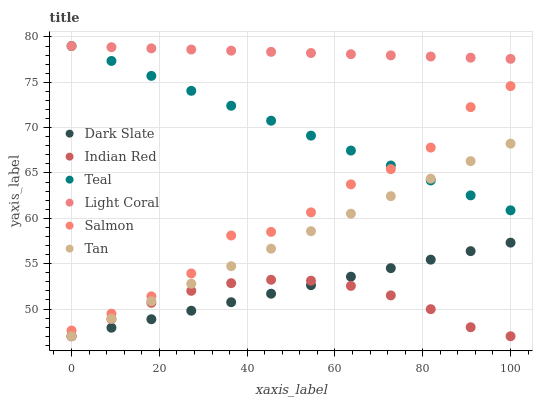Does Indian Red have the minimum area under the curve?
Answer yes or no. Yes. Does Light Coral have the maximum area under the curve?
Answer yes or no. Yes. Does Salmon have the minimum area under the curve?
Answer yes or no. No. Does Salmon have the maximum area under the curve?
Answer yes or no. No. Is Dark Slate the smoothest?
Answer yes or no. Yes. Is Salmon the roughest?
Answer yes or no. Yes. Is Light Coral the smoothest?
Answer yes or no. No. Is Light Coral the roughest?
Answer yes or no. No. Does Indian Red have the lowest value?
Answer yes or no. Yes. Does Salmon have the lowest value?
Answer yes or no. No. Does Teal have the highest value?
Answer yes or no. Yes. Does Salmon have the highest value?
Answer yes or no. No. Is Tan less than Salmon?
Answer yes or no. Yes. Is Salmon greater than Tan?
Answer yes or no. Yes. Does Dark Slate intersect Indian Red?
Answer yes or no. Yes. Is Dark Slate less than Indian Red?
Answer yes or no. No. Is Dark Slate greater than Indian Red?
Answer yes or no. No. Does Tan intersect Salmon?
Answer yes or no. No. 